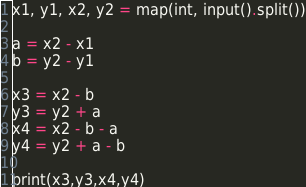Convert code to text. <code><loc_0><loc_0><loc_500><loc_500><_Python_>x1, y1, x2, y2 = map(int, input().split())

a = x2 - x1
b = y2 - y1

x3 = x2 - b
y3 = y2 + a
x4 = x2 - b - a
y4 = y2 + a - b

print(x3,y3,x4,y4)</code> 